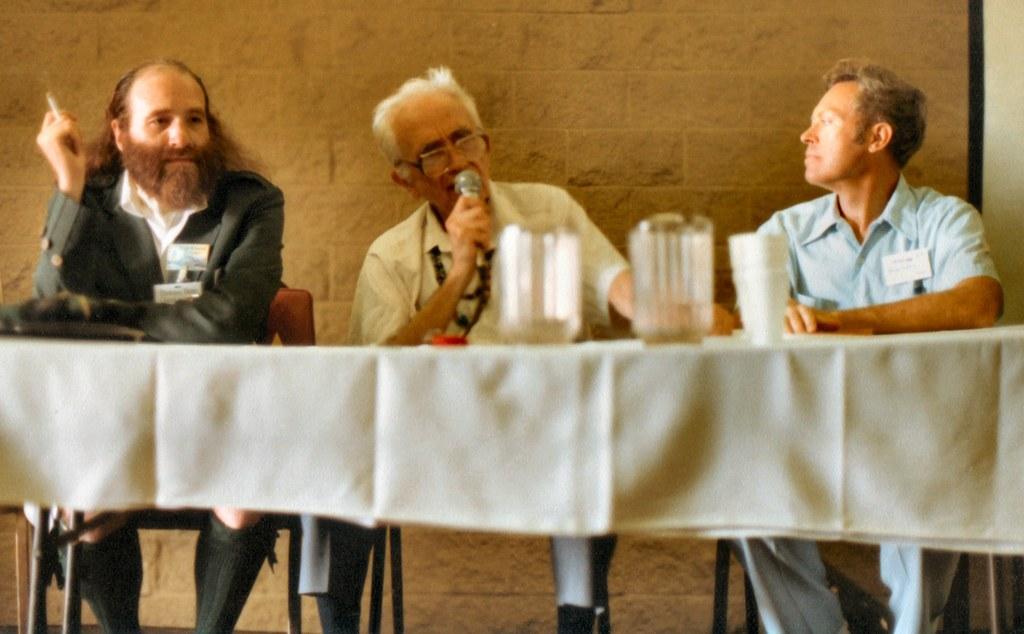Could you give a brief overview of what you see in this image? Three men are sitting at a table. Of them one is speaking with a mic in his hand. 